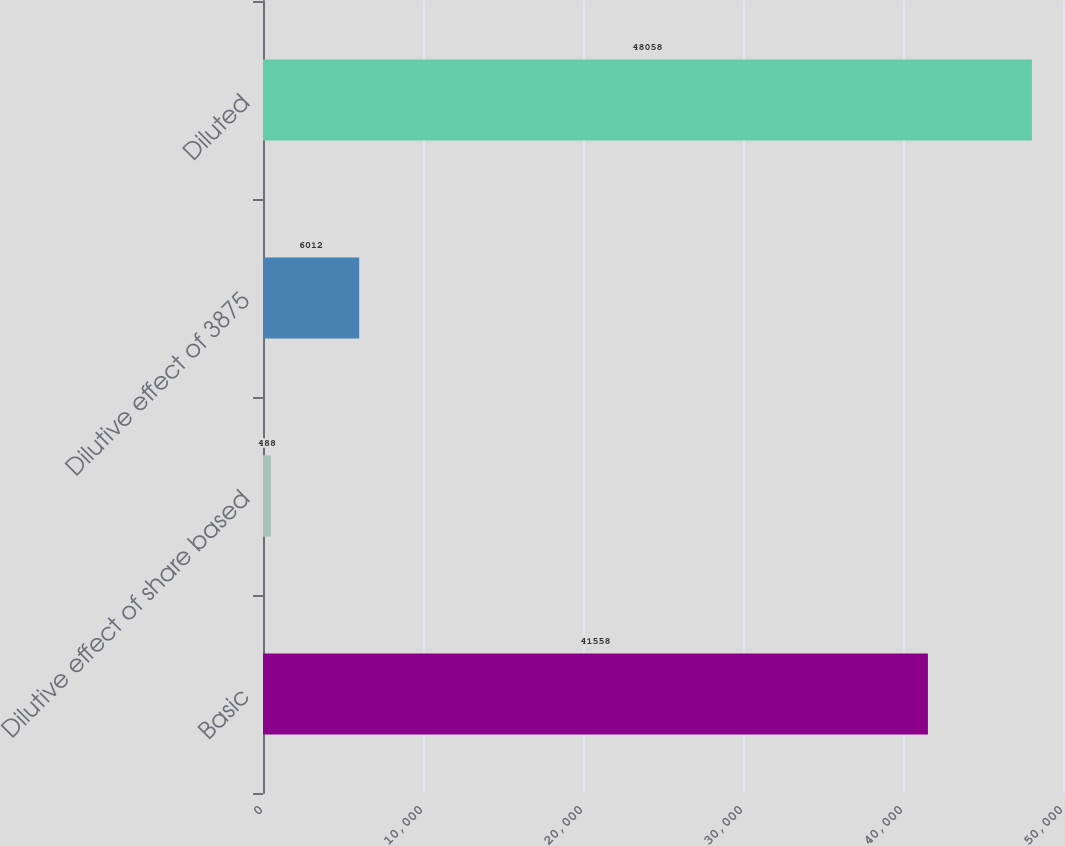Convert chart. <chart><loc_0><loc_0><loc_500><loc_500><bar_chart><fcel>Basic<fcel>Dilutive effect of share based<fcel>Dilutive effect of 3875<fcel>Diluted<nl><fcel>41558<fcel>488<fcel>6012<fcel>48058<nl></chart> 